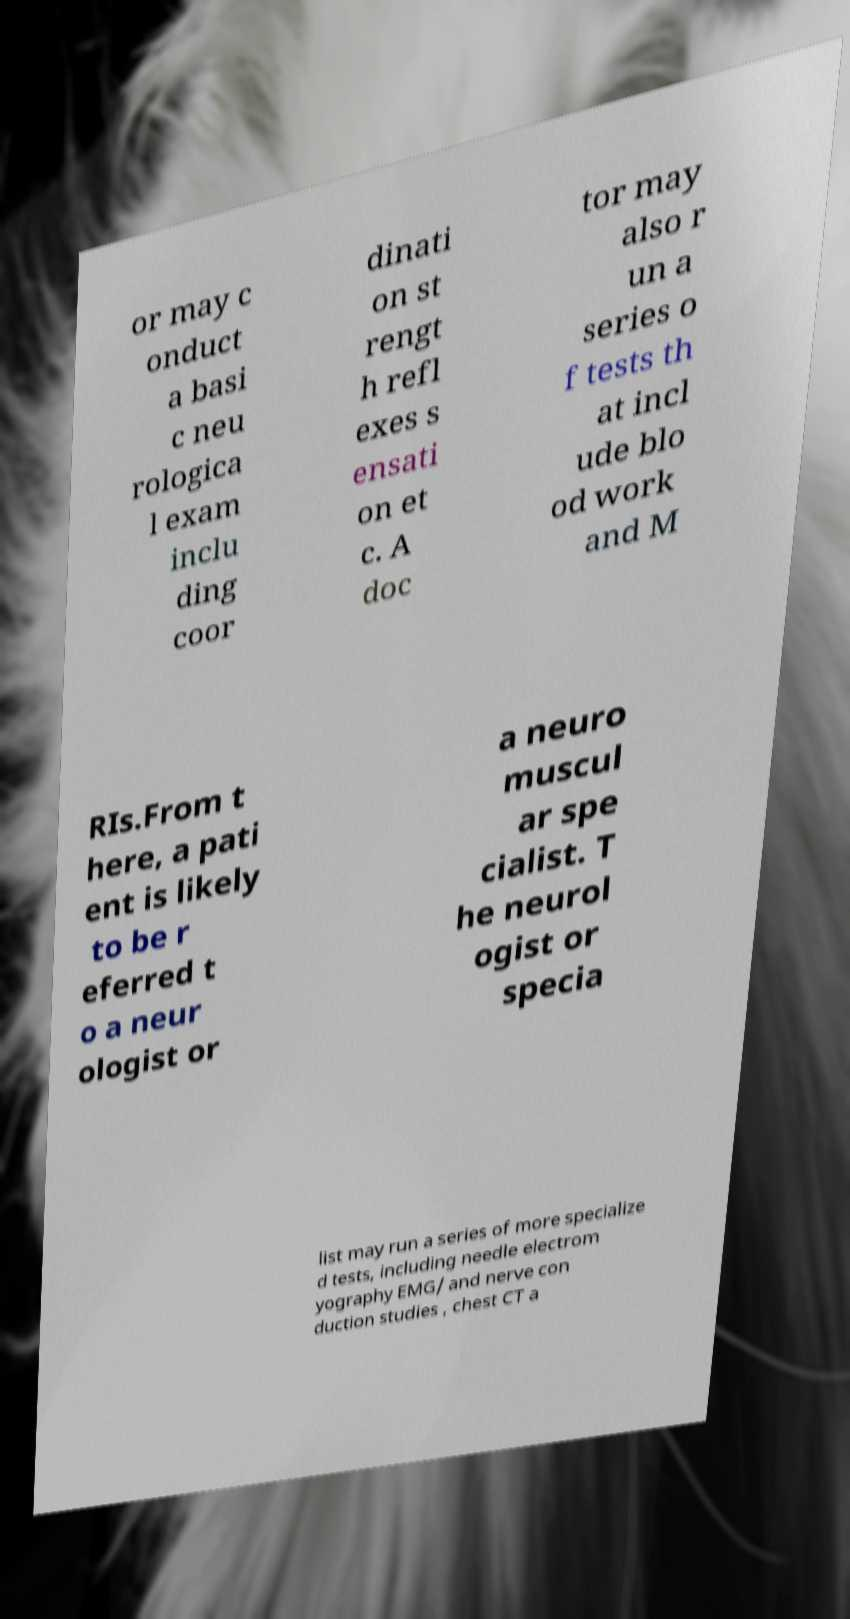Can you read and provide the text displayed in the image?This photo seems to have some interesting text. Can you extract and type it out for me? or may c onduct a basi c neu rologica l exam inclu ding coor dinati on st rengt h refl exes s ensati on et c. A doc tor may also r un a series o f tests th at incl ude blo od work and M RIs.From t here, a pati ent is likely to be r eferred t o a neur ologist or a neuro muscul ar spe cialist. T he neurol ogist or specia list may run a series of more specialize d tests, including needle electrom yography EMG/ and nerve con duction studies , chest CT a 